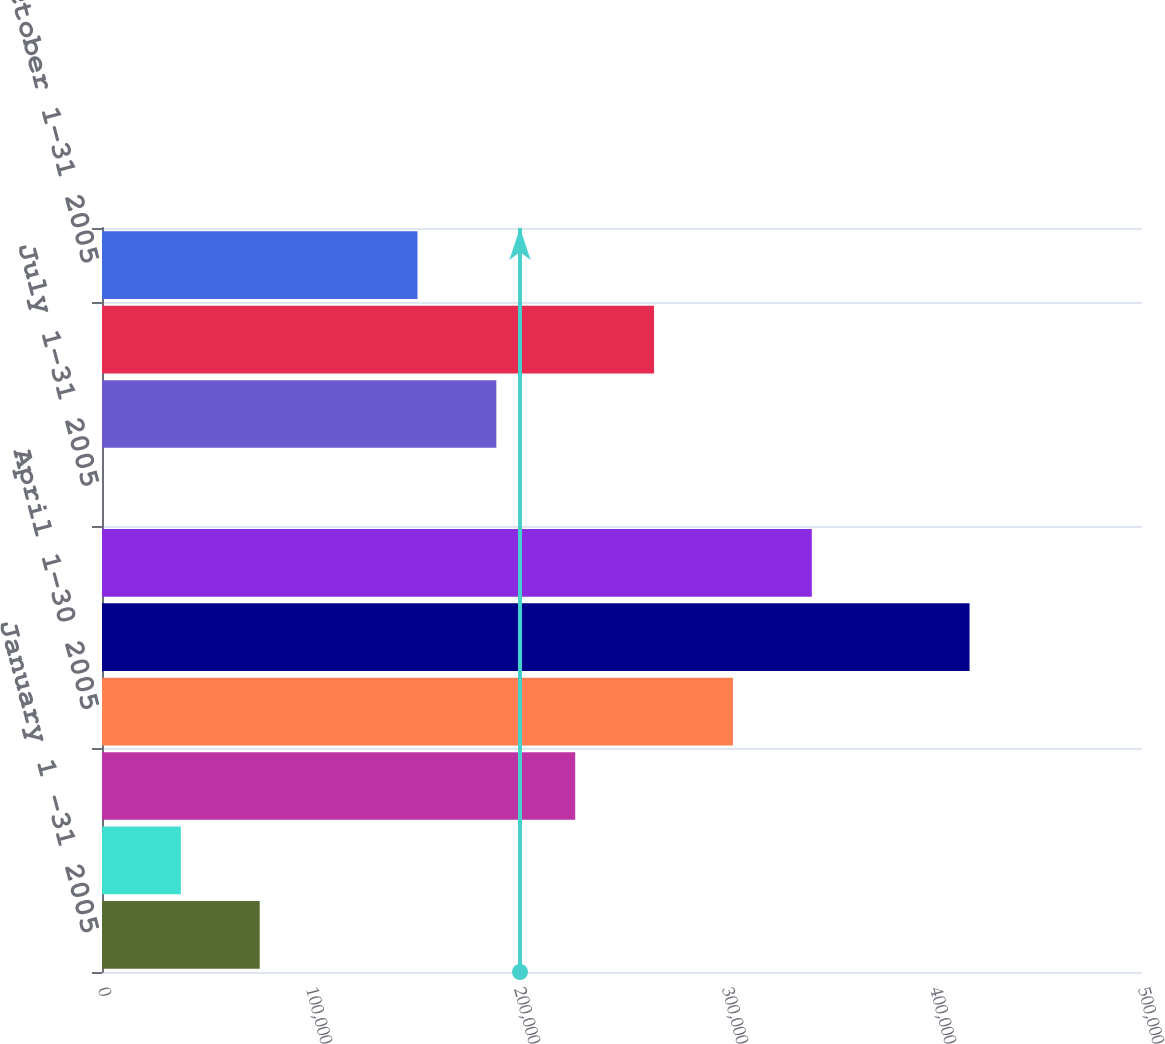Convert chart to OTSL. <chart><loc_0><loc_0><loc_500><loc_500><bar_chart><fcel>January 1 -31 2005<fcel>February 1-28 2005<fcel>March 1-31 2005<fcel>April 1-30 2005<fcel>May 1-31 2005<fcel>June 1-30 2005<fcel>July 1-31 2005<fcel>August 1-31 2005<fcel>September 1-30 2005<fcel>October 1-31 2005<nl><fcel>75834.6<fcel>37917.4<fcel>227503<fcel>303338<fcel>417089<fcel>341255<fcel>0.21<fcel>189586<fcel>265420<fcel>151669<nl></chart> 